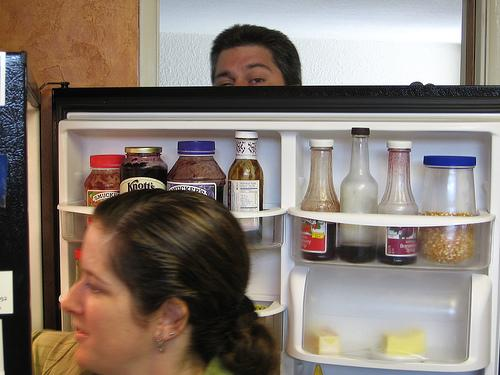Create a vivid depiction of the image by describing the woman's appearance and her surroundings. A lady with brown hair in a ponytail adorned by eye-catching earrings reaches into a refrigerator filled with butter, jellies, and bottles of various condiments. Give a summary of the scene in the image where the focus is on the refrigerator and its contents. An open refrigerator door reveals numerous condiments stored on the door shelves such as bottles of jelly, sauce, and sticks of butter. Write a description of the image that focuses on the interaction between the man and the woman. A woman browses the contents of a refrigerator while a man secretly stands behind the door, observing her with a cheeky grin. Provide a brief overview of the image with an emphasis on the items present in the refrigerator. The open refrigerator door showcases a variety of bottles, jars, and butter sticks, with a woman looking inside and a man playfully hiding behind it. Paint a picture with words of what the woman is doing in the image. A woman with her hair up in a ponytail is reaching into an open refrigerator, with various condiments and items on the refrigerator door. Mention a man and how he is engaging with the scene depicted in the image. A man is playfully standing behind the open refrigerator door, peeking over it and winking at the woman who is reaching inside. Compose a concise description of the image with equal emphasis on the woman, the man and the refrigerator. A woman with her hair up is reaching into a refrigerator filled with diverse items, while a man mischievously peeks from behind the door. Describe what the woman in the image is wearing and her actions. Try to make it sound intriguing. A stylish woman with highlighted hair and fashionable earrings carefully selects items from a well-stocked refrigerator. Explain the scene in the image by focusing on the man's action and the objects visible in the refrigerator. A curious man sneakily peeks over the refrigerator door, taking notice of condiments, butter sticks, and plentiful bottles lined up in rows. In a lighthearted tone, describe the scene where the woman is busy and the man is trying to be funny. A woman with a flair for fashion glances inside a well-stocked refrigerator while a cheeky man playfully hides, waiting to catch her attention. 